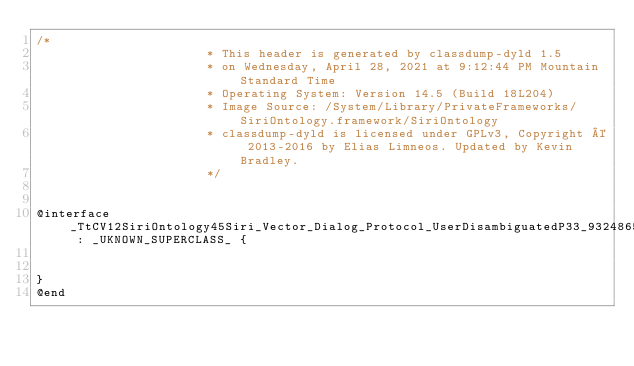<code> <loc_0><loc_0><loc_500><loc_500><_C_>/*
                       * This header is generated by classdump-dyld 1.5
                       * on Wednesday, April 28, 2021 at 9:12:44 PM Mountain Standard Time
                       * Operating System: Version 14.5 (Build 18L204)
                       * Image Source: /System/Library/PrivateFrameworks/SiriOntology.framework/SiriOntology
                       * classdump-dyld is licensed under GPLv3, Copyright © 2013-2016 by Elias Limneos. Updated by Kevin Bradley.
                       */


@interface _TtCV12SiriOntology45Siri_Vector_Dialog_Protocol_UserDisambiguatedP33_932486504AC56C44D36C9C054F9D1A2813_StorageClass : _UKNOWN_SUPERCLASS_ {


}
@end

</code> 